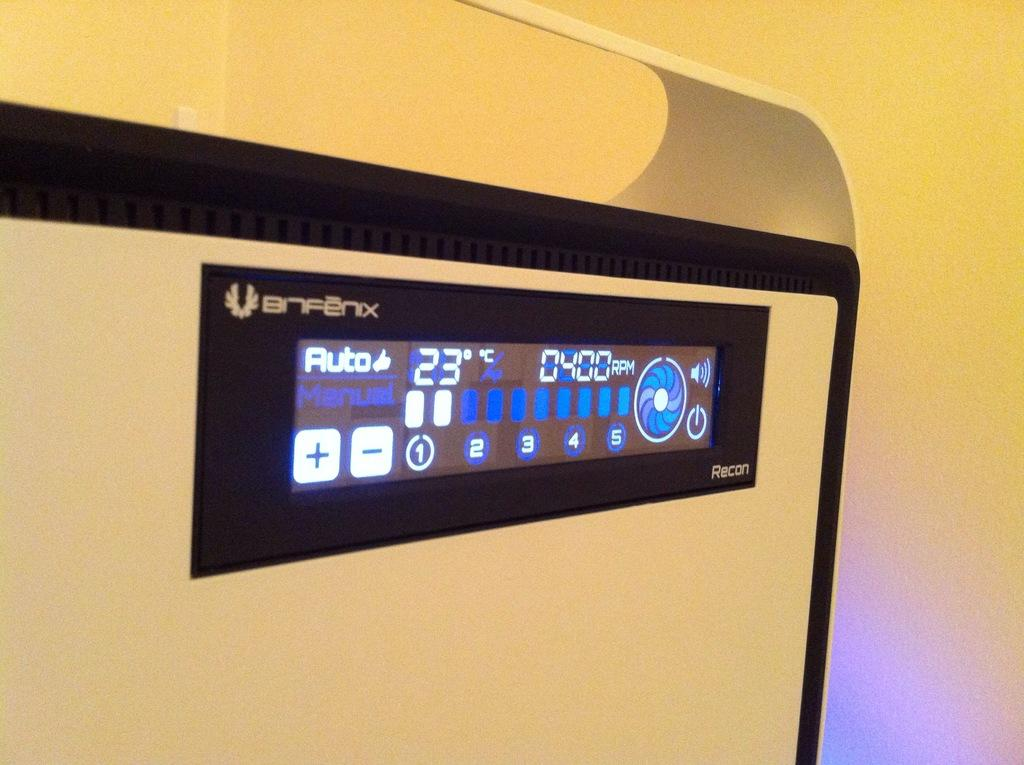<image>
Offer a succinct explanation of the picture presented. A digital display has a thumbs-up symbol next to the word auto. 